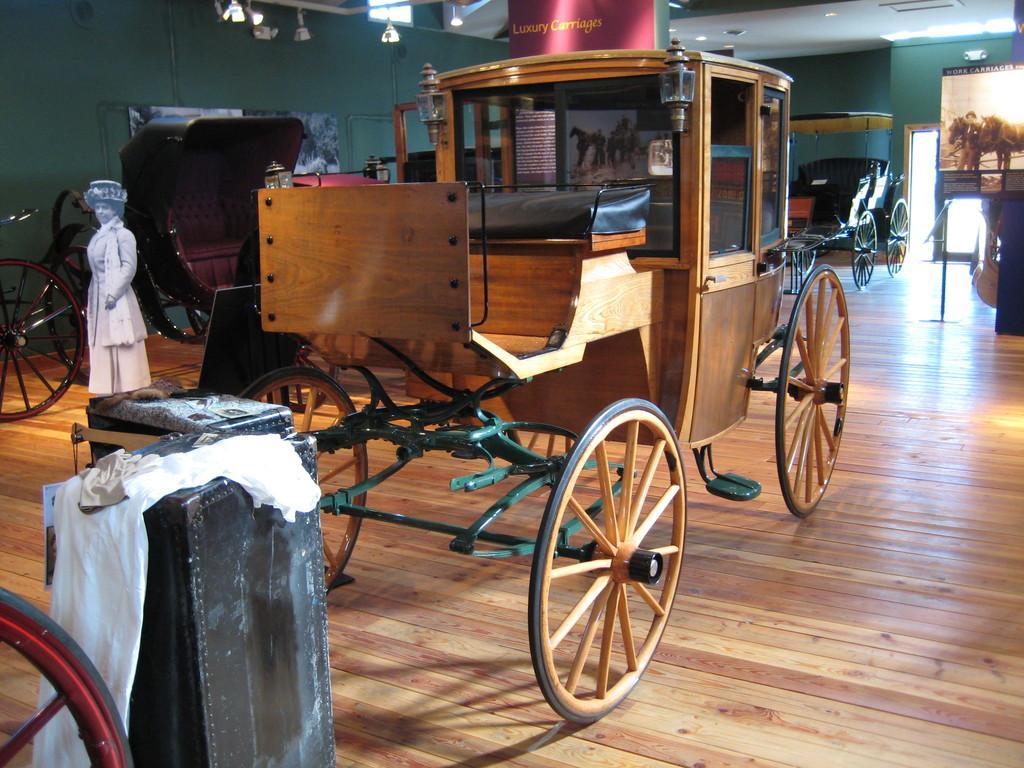Could you give a brief overview of what you see in this image? This image is taken indoors. At the bottom of the image there is a floor. At the top of the image there is a room. In the background there is a wall. There is a door. In the middle of the image there are a few cars parked on the floor. There are two boards with text on them. There is a statue of a woman. On the right side of the image there is a board with a text on it. 